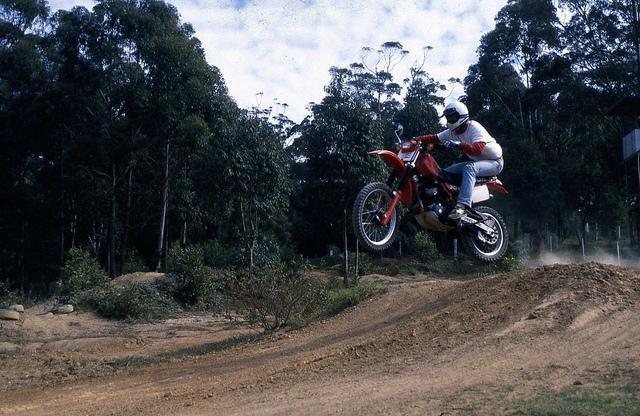How many motorcycles are there?
Give a very brief answer. 1. How many people are there?
Give a very brief answer. 1. How many giraffes are in the picture?
Give a very brief answer. 0. 